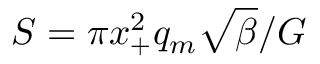Convert formula to latex. <formula><loc_0><loc_0><loc_500><loc_500>S = \pi x _ { + } ^ { 2 } q _ { m } \sqrt { \beta } / G</formula> 